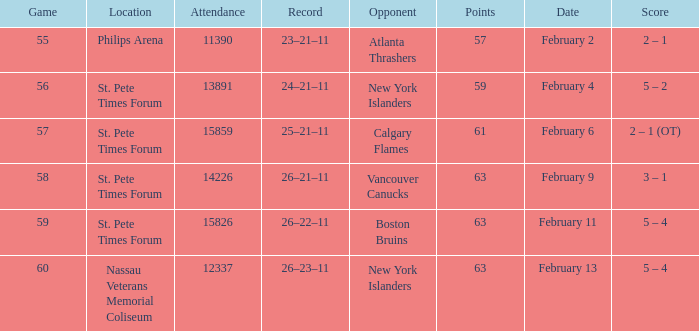What scores happened on February 11? 5 – 4. 